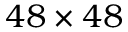Convert formula to latex. <formula><loc_0><loc_0><loc_500><loc_500>4 8 \times 4 8</formula> 